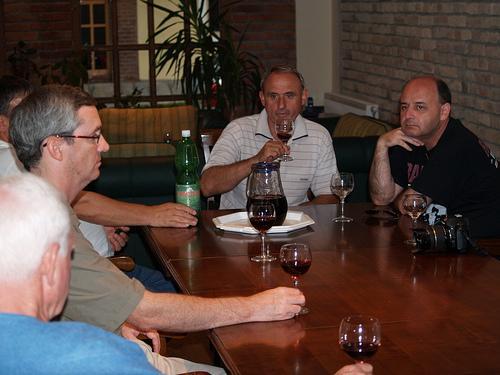What can happen if too much of this liquid is ingested?

Choices:
A) floatation
B) sickness
C) strangulation
D) hypnosis sickness 